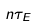<formula> <loc_0><loc_0><loc_500><loc_500>n \tau _ { E }</formula> 